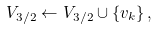Convert formula to latex. <formula><loc_0><loc_0><loc_500><loc_500>V _ { 3 / 2 } \leftarrow V _ { 3 / 2 } \cup \{ v _ { k } \} \, ,</formula> 